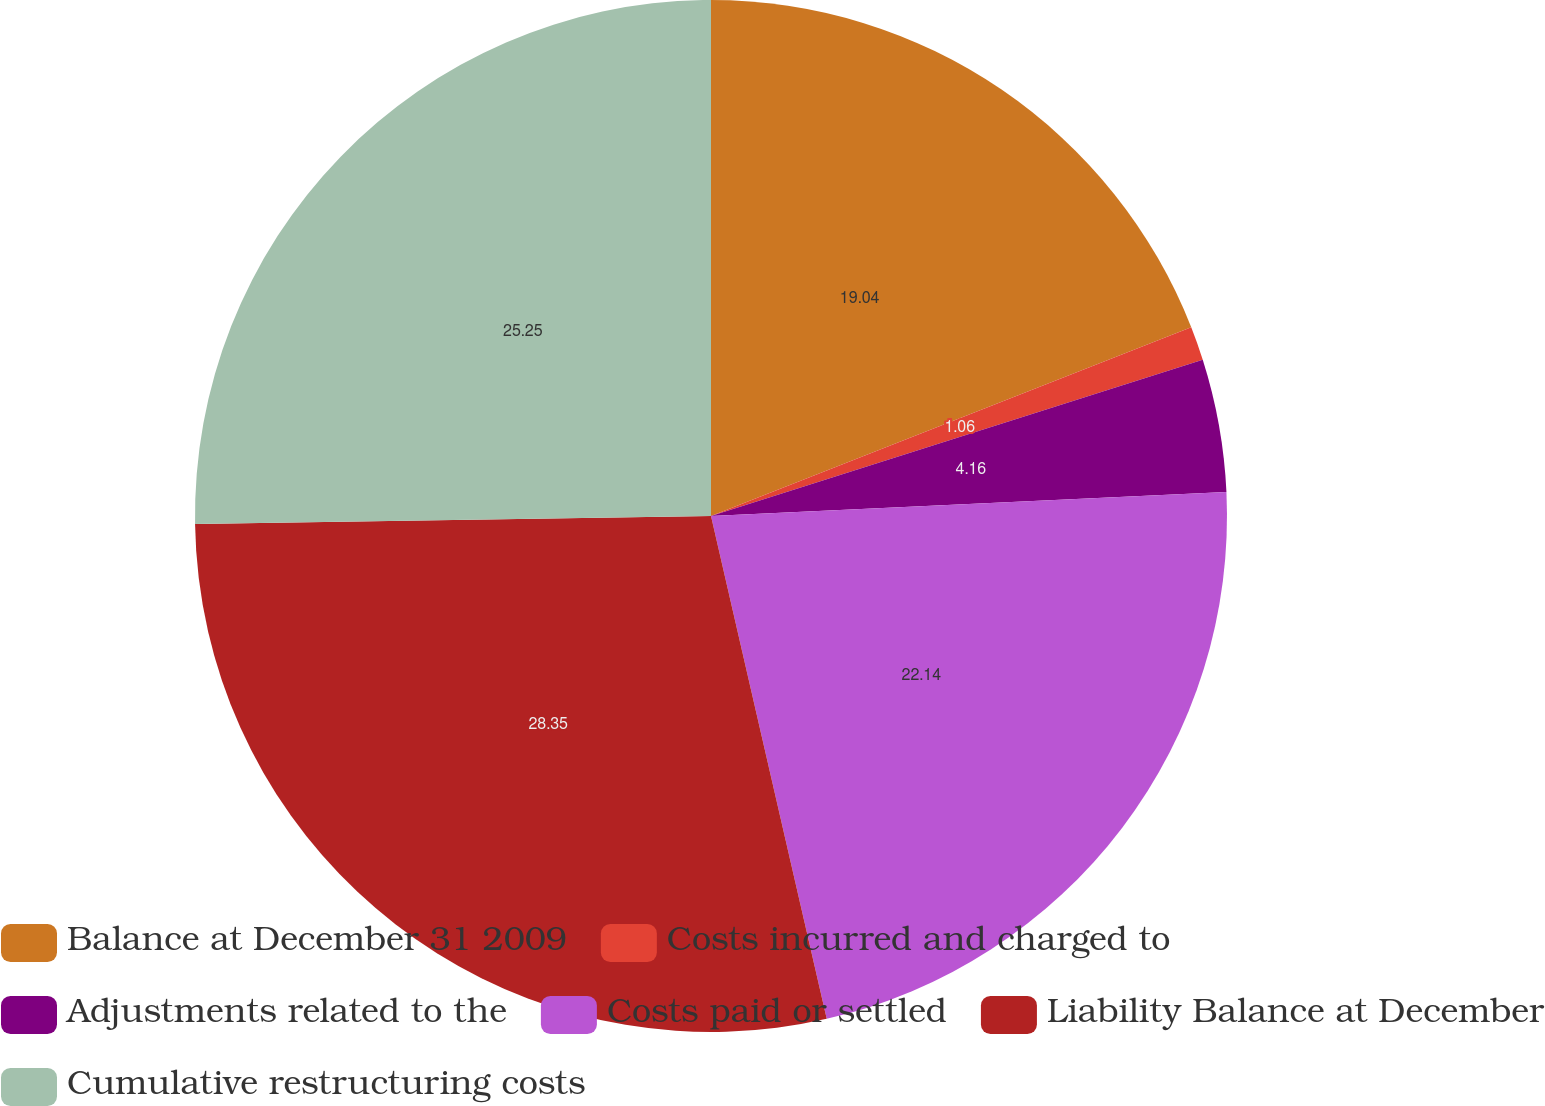Convert chart to OTSL. <chart><loc_0><loc_0><loc_500><loc_500><pie_chart><fcel>Balance at December 31 2009<fcel>Costs incurred and charged to<fcel>Adjustments related to the<fcel>Costs paid or settled<fcel>Liability Balance at December<fcel>Cumulative restructuring costs<nl><fcel>19.04%<fcel>1.06%<fcel>4.16%<fcel>22.14%<fcel>28.35%<fcel>25.25%<nl></chart> 